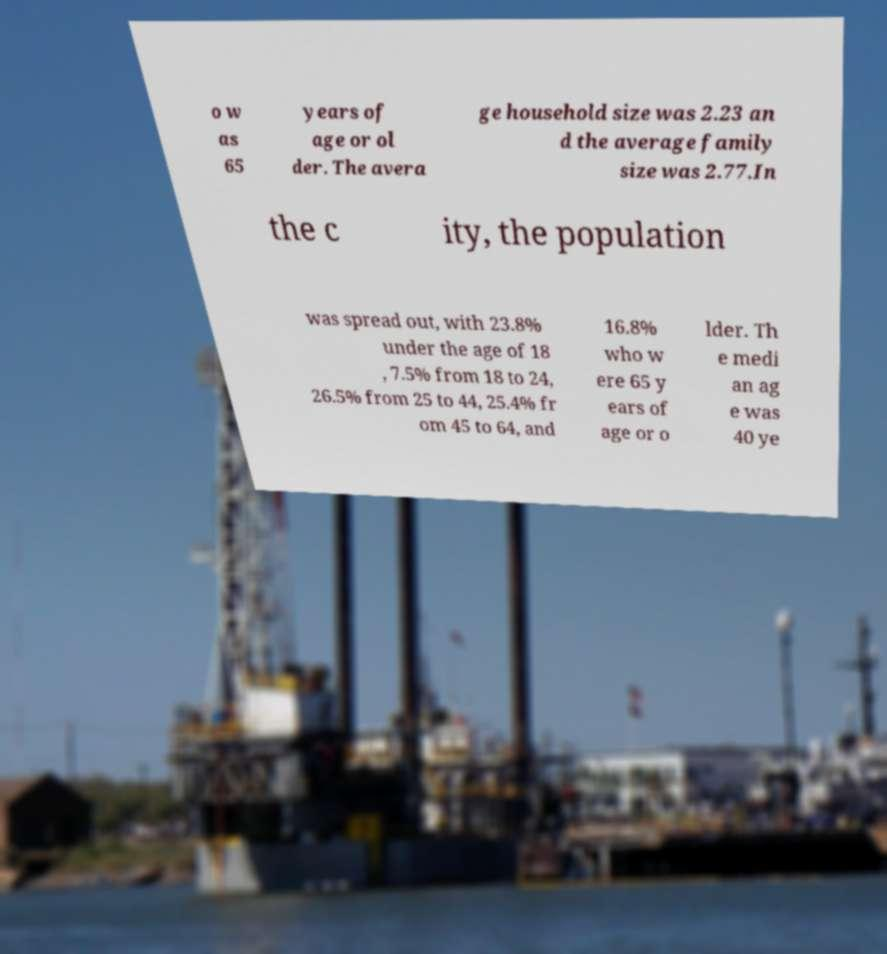Can you accurately transcribe the text from the provided image for me? o w as 65 years of age or ol der. The avera ge household size was 2.23 an d the average family size was 2.77.In the c ity, the population was spread out, with 23.8% under the age of 18 , 7.5% from 18 to 24, 26.5% from 25 to 44, 25.4% fr om 45 to 64, and 16.8% who w ere 65 y ears of age or o lder. Th e medi an ag e was 40 ye 